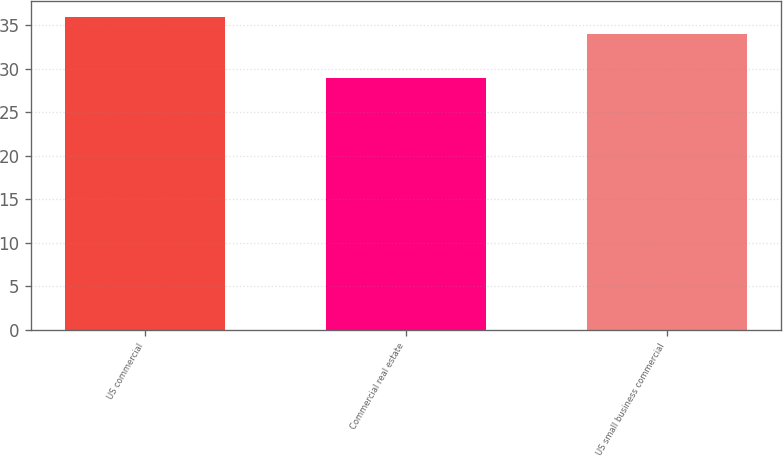<chart> <loc_0><loc_0><loc_500><loc_500><bar_chart><fcel>US commercial<fcel>Commercial real estate<fcel>US small business commercial<nl><fcel>36<fcel>29<fcel>34<nl></chart> 